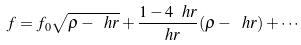<formula> <loc_0><loc_0><loc_500><loc_500>f = f _ { 0 } \sqrt { \rho - \ h r } + \frac { 1 - 4 \ h r } { \ h r } ( \rho - \ h r ) + \cdots</formula> 